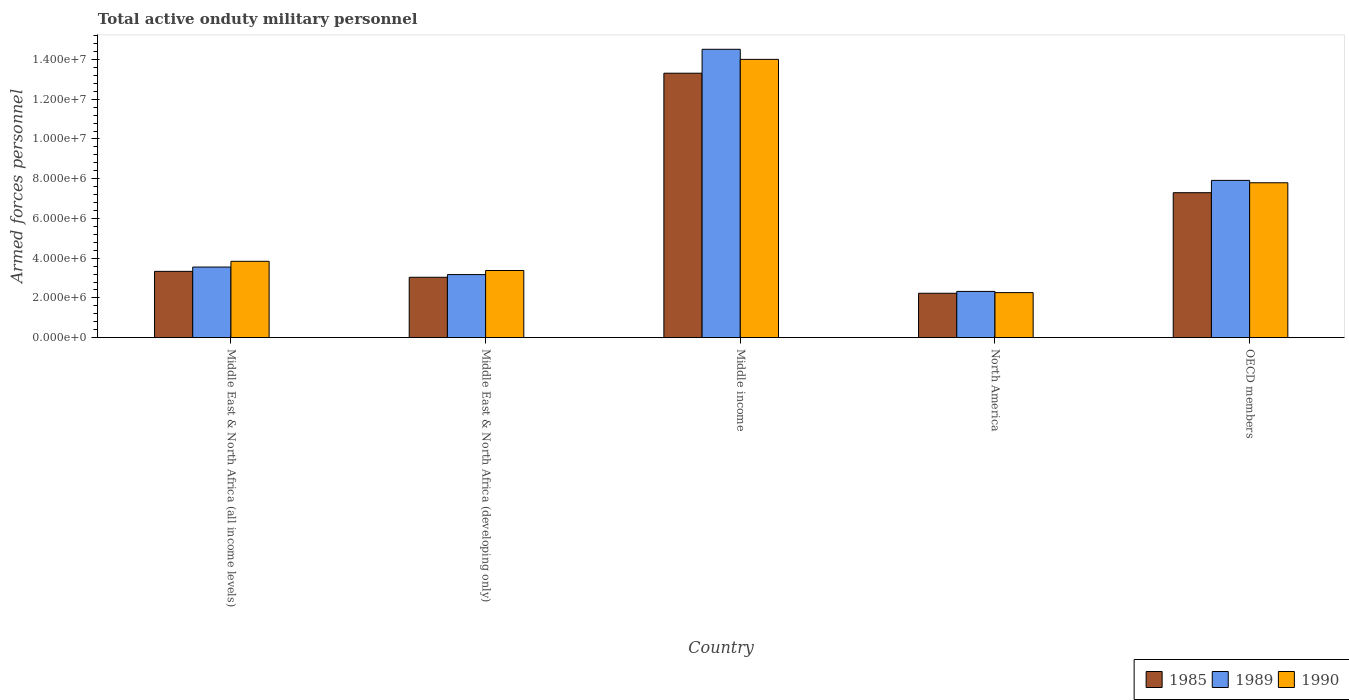How many different coloured bars are there?
Give a very brief answer. 3. How many groups of bars are there?
Make the answer very short. 5. Are the number of bars per tick equal to the number of legend labels?
Give a very brief answer. Yes. Are the number of bars on each tick of the X-axis equal?
Keep it short and to the point. Yes. How many bars are there on the 4th tick from the left?
Make the answer very short. 3. How many bars are there on the 3rd tick from the right?
Provide a short and direct response. 3. What is the label of the 5th group of bars from the left?
Provide a short and direct response. OECD members. In how many cases, is the number of bars for a given country not equal to the number of legend labels?
Offer a terse response. 0. What is the number of armed forces personnel in 1989 in Middle East & North Africa (all income levels)?
Offer a very short reply. 3.55e+06. Across all countries, what is the maximum number of armed forces personnel in 1989?
Your answer should be very brief. 1.45e+07. Across all countries, what is the minimum number of armed forces personnel in 1985?
Give a very brief answer. 2.23e+06. What is the total number of armed forces personnel in 1990 in the graph?
Ensure brevity in your answer.  3.13e+07. What is the difference between the number of armed forces personnel in 1989 in Middle income and that in OECD members?
Provide a short and direct response. 6.60e+06. What is the difference between the number of armed forces personnel in 1990 in Middle East & North Africa (developing only) and the number of armed forces personnel in 1989 in Middle income?
Provide a succinct answer. -1.11e+07. What is the average number of armed forces personnel in 1990 per country?
Provide a short and direct response. 6.26e+06. What is the difference between the number of armed forces personnel of/in 1989 and number of armed forces personnel of/in 1985 in OECD members?
Provide a succinct answer. 6.20e+05. What is the ratio of the number of armed forces personnel in 1990 in Middle East & North Africa (developing only) to that in North America?
Your answer should be very brief. 1.49. Is the number of armed forces personnel in 1990 in Middle income less than that in North America?
Provide a succinct answer. No. Is the difference between the number of armed forces personnel in 1989 in Middle East & North Africa (all income levels) and Middle income greater than the difference between the number of armed forces personnel in 1985 in Middle East & North Africa (all income levels) and Middle income?
Offer a terse response. No. What is the difference between the highest and the second highest number of armed forces personnel in 1990?
Make the answer very short. 6.21e+06. What is the difference between the highest and the lowest number of armed forces personnel in 1985?
Offer a terse response. 1.11e+07. In how many countries, is the number of armed forces personnel in 1990 greater than the average number of armed forces personnel in 1990 taken over all countries?
Provide a short and direct response. 2. What does the 3rd bar from the left in Middle East & North Africa (developing only) represents?
Give a very brief answer. 1990. How many countries are there in the graph?
Provide a succinct answer. 5. Does the graph contain any zero values?
Offer a very short reply. No. Where does the legend appear in the graph?
Offer a very short reply. Bottom right. How many legend labels are there?
Offer a very short reply. 3. What is the title of the graph?
Provide a short and direct response. Total active onduty military personnel. What is the label or title of the Y-axis?
Ensure brevity in your answer.  Armed forces personnel. What is the Armed forces personnel in 1985 in Middle East & North Africa (all income levels)?
Your answer should be compact. 3.34e+06. What is the Armed forces personnel of 1989 in Middle East & North Africa (all income levels)?
Your answer should be very brief. 3.55e+06. What is the Armed forces personnel of 1990 in Middle East & North Africa (all income levels)?
Offer a terse response. 3.84e+06. What is the Armed forces personnel in 1985 in Middle East & North Africa (developing only)?
Provide a succinct answer. 3.04e+06. What is the Armed forces personnel of 1989 in Middle East & North Africa (developing only)?
Keep it short and to the point. 3.18e+06. What is the Armed forces personnel of 1990 in Middle East & North Africa (developing only)?
Offer a terse response. 3.38e+06. What is the Armed forces personnel of 1985 in Middle income?
Provide a succinct answer. 1.33e+07. What is the Armed forces personnel of 1989 in Middle income?
Your answer should be compact. 1.45e+07. What is the Armed forces personnel in 1990 in Middle income?
Offer a very short reply. 1.40e+07. What is the Armed forces personnel of 1985 in North America?
Make the answer very short. 2.23e+06. What is the Armed forces personnel in 1989 in North America?
Your response must be concise. 2.33e+06. What is the Armed forces personnel of 1990 in North America?
Keep it short and to the point. 2.27e+06. What is the Armed forces personnel of 1985 in OECD members?
Offer a terse response. 7.30e+06. What is the Armed forces personnel in 1989 in OECD members?
Make the answer very short. 7.92e+06. What is the Armed forces personnel in 1990 in OECD members?
Keep it short and to the point. 7.80e+06. Across all countries, what is the maximum Armed forces personnel in 1985?
Offer a terse response. 1.33e+07. Across all countries, what is the maximum Armed forces personnel of 1989?
Ensure brevity in your answer.  1.45e+07. Across all countries, what is the maximum Armed forces personnel of 1990?
Offer a terse response. 1.40e+07. Across all countries, what is the minimum Armed forces personnel of 1985?
Give a very brief answer. 2.23e+06. Across all countries, what is the minimum Armed forces personnel of 1989?
Provide a short and direct response. 2.33e+06. Across all countries, what is the minimum Armed forces personnel in 1990?
Your answer should be compact. 2.27e+06. What is the total Armed forces personnel in 1985 in the graph?
Keep it short and to the point. 2.92e+07. What is the total Armed forces personnel of 1989 in the graph?
Provide a succinct answer. 3.15e+07. What is the total Armed forces personnel in 1990 in the graph?
Ensure brevity in your answer.  3.13e+07. What is the difference between the Armed forces personnel in 1985 in Middle East & North Africa (all income levels) and that in Middle East & North Africa (developing only)?
Your answer should be very brief. 2.98e+05. What is the difference between the Armed forces personnel of 1989 in Middle East & North Africa (all income levels) and that in Middle East & North Africa (developing only)?
Offer a very short reply. 3.79e+05. What is the difference between the Armed forces personnel in 1990 in Middle East & North Africa (all income levels) and that in Middle East & North Africa (developing only)?
Your response must be concise. 4.62e+05. What is the difference between the Armed forces personnel of 1985 in Middle East & North Africa (all income levels) and that in Middle income?
Offer a terse response. -9.97e+06. What is the difference between the Armed forces personnel in 1989 in Middle East & North Africa (all income levels) and that in Middle income?
Provide a succinct answer. -1.10e+07. What is the difference between the Armed forces personnel in 1990 in Middle East & North Africa (all income levels) and that in Middle income?
Offer a terse response. -1.02e+07. What is the difference between the Armed forces personnel in 1985 in Middle East & North Africa (all income levels) and that in North America?
Provide a short and direct response. 1.10e+06. What is the difference between the Armed forces personnel of 1989 in Middle East & North Africa (all income levels) and that in North America?
Provide a succinct answer. 1.23e+06. What is the difference between the Armed forces personnel in 1990 in Middle East & North Africa (all income levels) and that in North America?
Your answer should be compact. 1.58e+06. What is the difference between the Armed forces personnel in 1985 in Middle East & North Africa (all income levels) and that in OECD members?
Your answer should be compact. -3.96e+06. What is the difference between the Armed forces personnel of 1989 in Middle East & North Africa (all income levels) and that in OECD members?
Offer a very short reply. -4.36e+06. What is the difference between the Armed forces personnel of 1990 in Middle East & North Africa (all income levels) and that in OECD members?
Offer a very short reply. -3.95e+06. What is the difference between the Armed forces personnel in 1985 in Middle East & North Africa (developing only) and that in Middle income?
Your answer should be very brief. -1.03e+07. What is the difference between the Armed forces personnel of 1989 in Middle East & North Africa (developing only) and that in Middle income?
Your answer should be compact. -1.13e+07. What is the difference between the Armed forces personnel in 1990 in Middle East & North Africa (developing only) and that in Middle income?
Provide a succinct answer. -1.06e+07. What is the difference between the Armed forces personnel in 1985 in Middle East & North Africa (developing only) and that in North America?
Your answer should be very brief. 8.05e+05. What is the difference between the Armed forces personnel of 1989 in Middle East & North Africa (developing only) and that in North America?
Your answer should be compact. 8.47e+05. What is the difference between the Armed forces personnel in 1990 in Middle East & North Africa (developing only) and that in North America?
Provide a succinct answer. 1.11e+06. What is the difference between the Armed forces personnel of 1985 in Middle East & North Africa (developing only) and that in OECD members?
Your response must be concise. -4.26e+06. What is the difference between the Armed forces personnel of 1989 in Middle East & North Africa (developing only) and that in OECD members?
Ensure brevity in your answer.  -4.74e+06. What is the difference between the Armed forces personnel in 1990 in Middle East & North Africa (developing only) and that in OECD members?
Provide a short and direct response. -4.42e+06. What is the difference between the Armed forces personnel of 1985 in Middle income and that in North America?
Provide a short and direct response. 1.11e+07. What is the difference between the Armed forces personnel of 1989 in Middle income and that in North America?
Your answer should be very brief. 1.22e+07. What is the difference between the Armed forces personnel in 1990 in Middle income and that in North America?
Keep it short and to the point. 1.17e+07. What is the difference between the Armed forces personnel in 1985 in Middle income and that in OECD members?
Provide a succinct answer. 6.01e+06. What is the difference between the Armed forces personnel of 1989 in Middle income and that in OECD members?
Make the answer very short. 6.60e+06. What is the difference between the Armed forces personnel of 1990 in Middle income and that in OECD members?
Offer a very short reply. 6.21e+06. What is the difference between the Armed forces personnel of 1985 in North America and that in OECD members?
Offer a very short reply. -5.06e+06. What is the difference between the Armed forces personnel of 1989 in North America and that in OECD members?
Make the answer very short. -5.59e+06. What is the difference between the Armed forces personnel in 1990 in North America and that in OECD members?
Provide a short and direct response. -5.53e+06. What is the difference between the Armed forces personnel of 1985 in Middle East & North Africa (all income levels) and the Armed forces personnel of 1989 in Middle East & North Africa (developing only)?
Offer a terse response. 1.63e+05. What is the difference between the Armed forces personnel in 1985 in Middle East & North Africa (all income levels) and the Armed forces personnel in 1990 in Middle East & North Africa (developing only)?
Provide a short and direct response. -4.33e+04. What is the difference between the Armed forces personnel of 1989 in Middle East & North Africa (all income levels) and the Armed forces personnel of 1990 in Middle East & North Africa (developing only)?
Your answer should be compact. 1.73e+05. What is the difference between the Armed forces personnel in 1985 in Middle East & North Africa (all income levels) and the Armed forces personnel in 1989 in Middle income?
Make the answer very short. -1.12e+07. What is the difference between the Armed forces personnel in 1985 in Middle East & North Africa (all income levels) and the Armed forces personnel in 1990 in Middle income?
Make the answer very short. -1.07e+07. What is the difference between the Armed forces personnel of 1989 in Middle East & North Africa (all income levels) and the Armed forces personnel of 1990 in Middle income?
Offer a terse response. -1.05e+07. What is the difference between the Armed forces personnel of 1985 in Middle East & North Africa (all income levels) and the Armed forces personnel of 1989 in North America?
Make the answer very short. 1.01e+06. What is the difference between the Armed forces personnel of 1985 in Middle East & North Africa (all income levels) and the Armed forces personnel of 1990 in North America?
Provide a short and direct response. 1.07e+06. What is the difference between the Armed forces personnel in 1989 in Middle East & North Africa (all income levels) and the Armed forces personnel in 1990 in North America?
Provide a succinct answer. 1.29e+06. What is the difference between the Armed forces personnel in 1985 in Middle East & North Africa (all income levels) and the Armed forces personnel in 1989 in OECD members?
Keep it short and to the point. -4.58e+06. What is the difference between the Armed forces personnel of 1985 in Middle East & North Africa (all income levels) and the Armed forces personnel of 1990 in OECD members?
Keep it short and to the point. -4.46e+06. What is the difference between the Armed forces personnel of 1989 in Middle East & North Africa (all income levels) and the Armed forces personnel of 1990 in OECD members?
Provide a short and direct response. -4.24e+06. What is the difference between the Armed forces personnel in 1985 in Middle East & North Africa (developing only) and the Armed forces personnel in 1989 in Middle income?
Keep it short and to the point. -1.15e+07. What is the difference between the Armed forces personnel of 1985 in Middle East & North Africa (developing only) and the Armed forces personnel of 1990 in Middle income?
Make the answer very short. -1.10e+07. What is the difference between the Armed forces personnel of 1989 in Middle East & North Africa (developing only) and the Armed forces personnel of 1990 in Middle income?
Offer a very short reply. -1.08e+07. What is the difference between the Armed forces personnel in 1985 in Middle East & North Africa (developing only) and the Armed forces personnel in 1989 in North America?
Your response must be concise. 7.11e+05. What is the difference between the Armed forces personnel in 1985 in Middle East & North Africa (developing only) and the Armed forces personnel in 1990 in North America?
Keep it short and to the point. 7.72e+05. What is the difference between the Armed forces personnel in 1989 in Middle East & North Africa (developing only) and the Armed forces personnel in 1990 in North America?
Give a very brief answer. 9.08e+05. What is the difference between the Armed forces personnel in 1985 in Middle East & North Africa (developing only) and the Armed forces personnel in 1989 in OECD members?
Offer a terse response. -4.88e+06. What is the difference between the Armed forces personnel in 1985 in Middle East & North Africa (developing only) and the Armed forces personnel in 1990 in OECD members?
Offer a terse response. -4.76e+06. What is the difference between the Armed forces personnel of 1989 in Middle East & North Africa (developing only) and the Armed forces personnel of 1990 in OECD members?
Ensure brevity in your answer.  -4.62e+06. What is the difference between the Armed forces personnel of 1985 in Middle income and the Armed forces personnel of 1989 in North America?
Your answer should be compact. 1.10e+07. What is the difference between the Armed forces personnel in 1985 in Middle income and the Armed forces personnel in 1990 in North America?
Provide a succinct answer. 1.10e+07. What is the difference between the Armed forces personnel of 1989 in Middle income and the Armed forces personnel of 1990 in North America?
Provide a succinct answer. 1.22e+07. What is the difference between the Armed forces personnel in 1985 in Middle income and the Armed forces personnel in 1989 in OECD members?
Provide a succinct answer. 5.39e+06. What is the difference between the Armed forces personnel of 1985 in Middle income and the Armed forces personnel of 1990 in OECD members?
Your answer should be compact. 5.51e+06. What is the difference between the Armed forces personnel in 1989 in Middle income and the Armed forces personnel in 1990 in OECD members?
Your answer should be very brief. 6.72e+06. What is the difference between the Armed forces personnel of 1985 in North America and the Armed forces personnel of 1989 in OECD members?
Offer a very short reply. -5.68e+06. What is the difference between the Armed forces personnel of 1985 in North America and the Armed forces personnel of 1990 in OECD members?
Offer a terse response. -5.56e+06. What is the difference between the Armed forces personnel of 1989 in North America and the Armed forces personnel of 1990 in OECD members?
Keep it short and to the point. -5.47e+06. What is the average Armed forces personnel in 1985 per country?
Give a very brief answer. 5.84e+06. What is the average Armed forces personnel of 1989 per country?
Your response must be concise. 6.30e+06. What is the average Armed forces personnel in 1990 per country?
Ensure brevity in your answer.  6.26e+06. What is the difference between the Armed forces personnel of 1985 and Armed forces personnel of 1989 in Middle East & North Africa (all income levels)?
Provide a short and direct response. -2.16e+05. What is the difference between the Armed forces personnel in 1985 and Armed forces personnel in 1990 in Middle East & North Africa (all income levels)?
Your answer should be compact. -5.05e+05. What is the difference between the Armed forces personnel of 1989 and Armed forces personnel of 1990 in Middle East & North Africa (all income levels)?
Your answer should be compact. -2.89e+05. What is the difference between the Armed forces personnel in 1985 and Armed forces personnel in 1989 in Middle East & North Africa (developing only)?
Provide a short and direct response. -1.36e+05. What is the difference between the Armed forces personnel in 1985 and Armed forces personnel in 1990 in Middle East & North Africa (developing only)?
Give a very brief answer. -3.42e+05. What is the difference between the Armed forces personnel in 1989 and Armed forces personnel in 1990 in Middle East & North Africa (developing only)?
Make the answer very short. -2.06e+05. What is the difference between the Armed forces personnel of 1985 and Armed forces personnel of 1989 in Middle income?
Offer a terse response. -1.20e+06. What is the difference between the Armed forces personnel of 1985 and Armed forces personnel of 1990 in Middle income?
Offer a terse response. -6.97e+05. What is the difference between the Armed forces personnel in 1989 and Armed forces personnel in 1990 in Middle income?
Give a very brief answer. 5.07e+05. What is the difference between the Armed forces personnel of 1985 and Armed forces personnel of 1989 in North America?
Offer a very short reply. -9.34e+04. What is the difference between the Armed forces personnel in 1985 and Armed forces personnel in 1990 in North America?
Provide a short and direct response. -3.24e+04. What is the difference between the Armed forces personnel of 1989 and Armed forces personnel of 1990 in North America?
Offer a terse response. 6.10e+04. What is the difference between the Armed forces personnel of 1985 and Armed forces personnel of 1989 in OECD members?
Provide a short and direct response. -6.20e+05. What is the difference between the Armed forces personnel in 1985 and Armed forces personnel in 1990 in OECD members?
Offer a terse response. -5.00e+05. What is the ratio of the Armed forces personnel of 1985 in Middle East & North Africa (all income levels) to that in Middle East & North Africa (developing only)?
Your response must be concise. 1.1. What is the ratio of the Armed forces personnel in 1989 in Middle East & North Africa (all income levels) to that in Middle East & North Africa (developing only)?
Make the answer very short. 1.12. What is the ratio of the Armed forces personnel of 1990 in Middle East & North Africa (all income levels) to that in Middle East & North Africa (developing only)?
Provide a short and direct response. 1.14. What is the ratio of the Armed forces personnel of 1985 in Middle East & North Africa (all income levels) to that in Middle income?
Ensure brevity in your answer.  0.25. What is the ratio of the Armed forces personnel in 1989 in Middle East & North Africa (all income levels) to that in Middle income?
Your answer should be compact. 0.24. What is the ratio of the Armed forces personnel in 1990 in Middle East & North Africa (all income levels) to that in Middle income?
Provide a short and direct response. 0.27. What is the ratio of the Armed forces personnel of 1985 in Middle East & North Africa (all income levels) to that in North America?
Keep it short and to the point. 1.49. What is the ratio of the Armed forces personnel of 1989 in Middle East & North Africa (all income levels) to that in North America?
Keep it short and to the point. 1.53. What is the ratio of the Armed forces personnel of 1990 in Middle East & North Africa (all income levels) to that in North America?
Make the answer very short. 1.7. What is the ratio of the Armed forces personnel of 1985 in Middle East & North Africa (all income levels) to that in OECD members?
Offer a very short reply. 0.46. What is the ratio of the Armed forces personnel in 1989 in Middle East & North Africa (all income levels) to that in OECD members?
Ensure brevity in your answer.  0.45. What is the ratio of the Armed forces personnel in 1990 in Middle East & North Africa (all income levels) to that in OECD members?
Offer a very short reply. 0.49. What is the ratio of the Armed forces personnel in 1985 in Middle East & North Africa (developing only) to that in Middle income?
Your answer should be very brief. 0.23. What is the ratio of the Armed forces personnel in 1989 in Middle East & North Africa (developing only) to that in Middle income?
Ensure brevity in your answer.  0.22. What is the ratio of the Armed forces personnel of 1990 in Middle East & North Africa (developing only) to that in Middle income?
Keep it short and to the point. 0.24. What is the ratio of the Armed forces personnel in 1985 in Middle East & North Africa (developing only) to that in North America?
Provide a short and direct response. 1.36. What is the ratio of the Armed forces personnel in 1989 in Middle East & North Africa (developing only) to that in North America?
Ensure brevity in your answer.  1.36. What is the ratio of the Armed forces personnel of 1990 in Middle East & North Africa (developing only) to that in North America?
Ensure brevity in your answer.  1.49. What is the ratio of the Armed forces personnel in 1985 in Middle East & North Africa (developing only) to that in OECD members?
Ensure brevity in your answer.  0.42. What is the ratio of the Armed forces personnel of 1989 in Middle East & North Africa (developing only) to that in OECD members?
Make the answer very short. 0.4. What is the ratio of the Armed forces personnel in 1990 in Middle East & North Africa (developing only) to that in OECD members?
Make the answer very short. 0.43. What is the ratio of the Armed forces personnel of 1985 in Middle income to that in North America?
Your answer should be compact. 5.96. What is the ratio of the Armed forces personnel in 1989 in Middle income to that in North America?
Provide a succinct answer. 6.23. What is the ratio of the Armed forces personnel in 1990 in Middle income to that in North America?
Provide a succinct answer. 6.18. What is the ratio of the Armed forces personnel in 1985 in Middle income to that in OECD members?
Make the answer very short. 1.82. What is the ratio of the Armed forces personnel in 1989 in Middle income to that in OECD members?
Provide a succinct answer. 1.83. What is the ratio of the Armed forces personnel of 1990 in Middle income to that in OECD members?
Your answer should be compact. 1.8. What is the ratio of the Armed forces personnel in 1985 in North America to that in OECD members?
Offer a terse response. 0.31. What is the ratio of the Armed forces personnel in 1989 in North America to that in OECD members?
Keep it short and to the point. 0.29. What is the ratio of the Armed forces personnel of 1990 in North America to that in OECD members?
Give a very brief answer. 0.29. What is the difference between the highest and the second highest Armed forces personnel of 1985?
Your response must be concise. 6.01e+06. What is the difference between the highest and the second highest Armed forces personnel of 1989?
Provide a short and direct response. 6.60e+06. What is the difference between the highest and the second highest Armed forces personnel of 1990?
Your answer should be very brief. 6.21e+06. What is the difference between the highest and the lowest Armed forces personnel of 1985?
Your answer should be very brief. 1.11e+07. What is the difference between the highest and the lowest Armed forces personnel in 1989?
Your answer should be compact. 1.22e+07. What is the difference between the highest and the lowest Armed forces personnel in 1990?
Offer a terse response. 1.17e+07. 